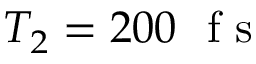Convert formula to latex. <formula><loc_0><loc_0><loc_500><loc_500>T _ { 2 } = 2 0 0 f s</formula> 